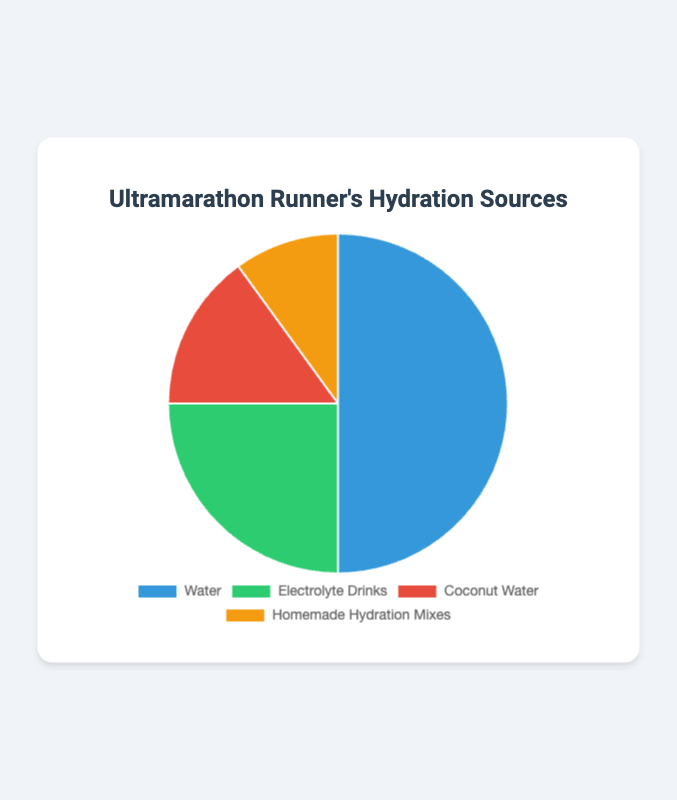What percentage of hydration sources comes from Electrolyte Drinks and Coconut Water combined? To find the total percentage from Electrolyte Drinks and Coconut Water, sum their individual percentages: 25% (Electrolyte Drinks) + 15% (Coconut Water) = 40%.
Answer: 40% Which hydration source is used the least during runs? The figure shows four hydration sources with their respective percentages. Homemade Hydration Mixes have the smallest percentage at 10%.
Answer: Homemade Hydration Mixes Is the proportion of Water usage greater than the combined usage of Coconut Water and Homemade Hydration Mixes? Compare the percentage of Water (50%) with the sum of Coconut Water (15%) and Homemade Hydration Mixes (10%): 50% (Water) is greater than 25% (15% + 10%).
Answer: Yes What is the ratio of Water to Electrolyte Drinks used for hydration? Divide the percentage of Water by the percentage of Electrolyte Drinks: 50/25 = 2. So, the ratio is 2:1.
Answer: 2:1 What fraction of hydration sources is not based on Water use? Subtract the percentage of Water (50%) from 100% to find the non-Water hydration sources: 100% - 50% = 50%.
Answer: 50% What's the percentage difference between the most used and the least used hydration source? Subtract the percentage of the least used source (10%, Homemade Hydration Mixes) from the most used source (50%, Water): 50% - 10% = 40%.
Answer: 40% If Coconut Water and Homemade Hydration Mixes are combined, do they exceed the usage of Electrolyte Drinks? Sum the percentages of Coconut Water (15%) and Homemade Hydration Mixes (10%) and compare to Electrolyte Drinks (25%): 15% + 10% = 25%. They are equal.
Answer: No, they are equal What is the proportion of Electrolyte Drinks to the total sum of all hydration sources? Divide the percentage of Electrolyte Drinks by the total percentage (100%): 25/100 = 0.25 or 25%.
Answer: 25% Which two hydration sources together account for exactly 40% of the total? Reviewing the individual percentages, Coconut Water (15%) and Homemade Hydration Mixes (10%) do not sum to 40%. Water and Electrolyte Drinks together do not sum to 40%. Electrolyte Drinks (25%) and Coconut Water (15%) combine to exactly 40%.
Answer: Electrolyte Drinks and Coconut Water How many different colors are used to represent the hydration sources in the pie chart? Based on the data, each of the four segments (Water, Electrolyte Drinks, Coconut Water, Homemade Hydration Mixes) is represented by a unique color.
Answer: Four 